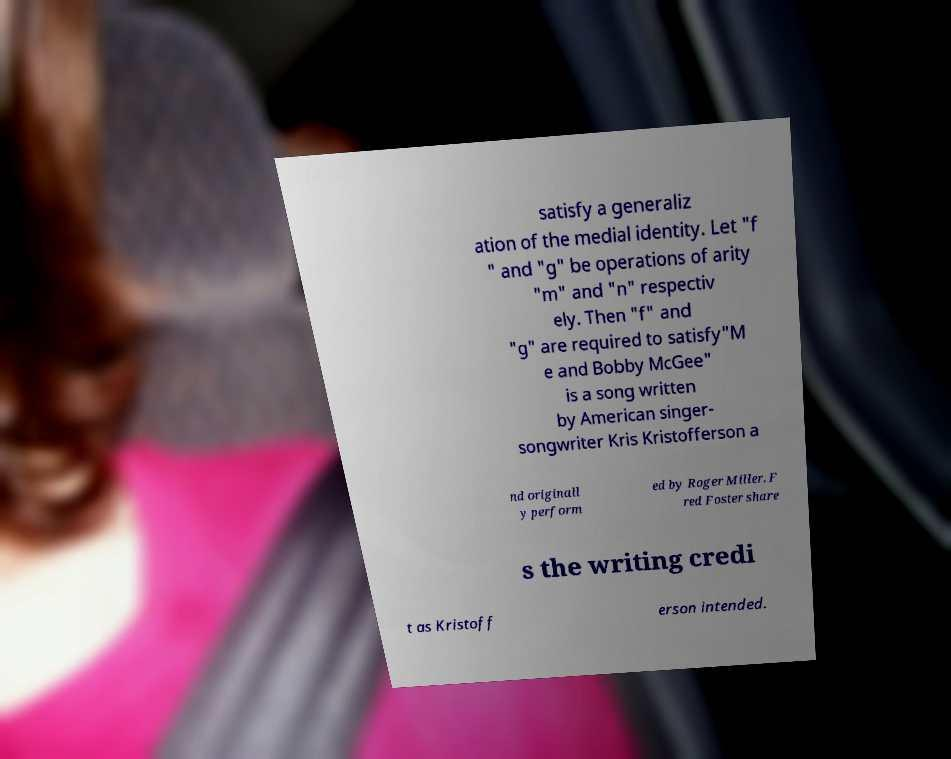Please read and relay the text visible in this image. What does it say? satisfy a generaliz ation of the medial identity. Let "f " and "g" be operations of arity "m" and "n" respectiv ely. Then "f" and "g" are required to satisfy"M e and Bobby McGee" is a song written by American singer- songwriter Kris Kristofferson a nd originall y perform ed by Roger Miller. F red Foster share s the writing credi t as Kristoff erson intended. 